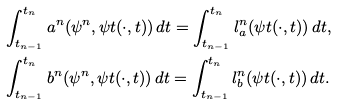Convert formula to latex. <formula><loc_0><loc_0><loc_500><loc_500>& \int _ { t _ { n - 1 } } ^ { t _ { n } } a ^ { n } ( \psi ^ { n } , \psi t ( \cdot , t ) ) \, d t = \int _ { t _ { n - 1 } } ^ { t _ { n } } l _ { a } ^ { n } ( \psi t ( \cdot , t ) ) \, d t , \\ & \int _ { t _ { n - 1 } } ^ { t _ { n } } b ^ { n } ( \psi ^ { n } , \psi t ( \cdot , t ) ) \, d t = \int _ { t _ { n - 1 } } ^ { t _ { n } } l _ { b } ^ { n } ( \psi t ( \cdot , t ) ) \, d t .</formula> 